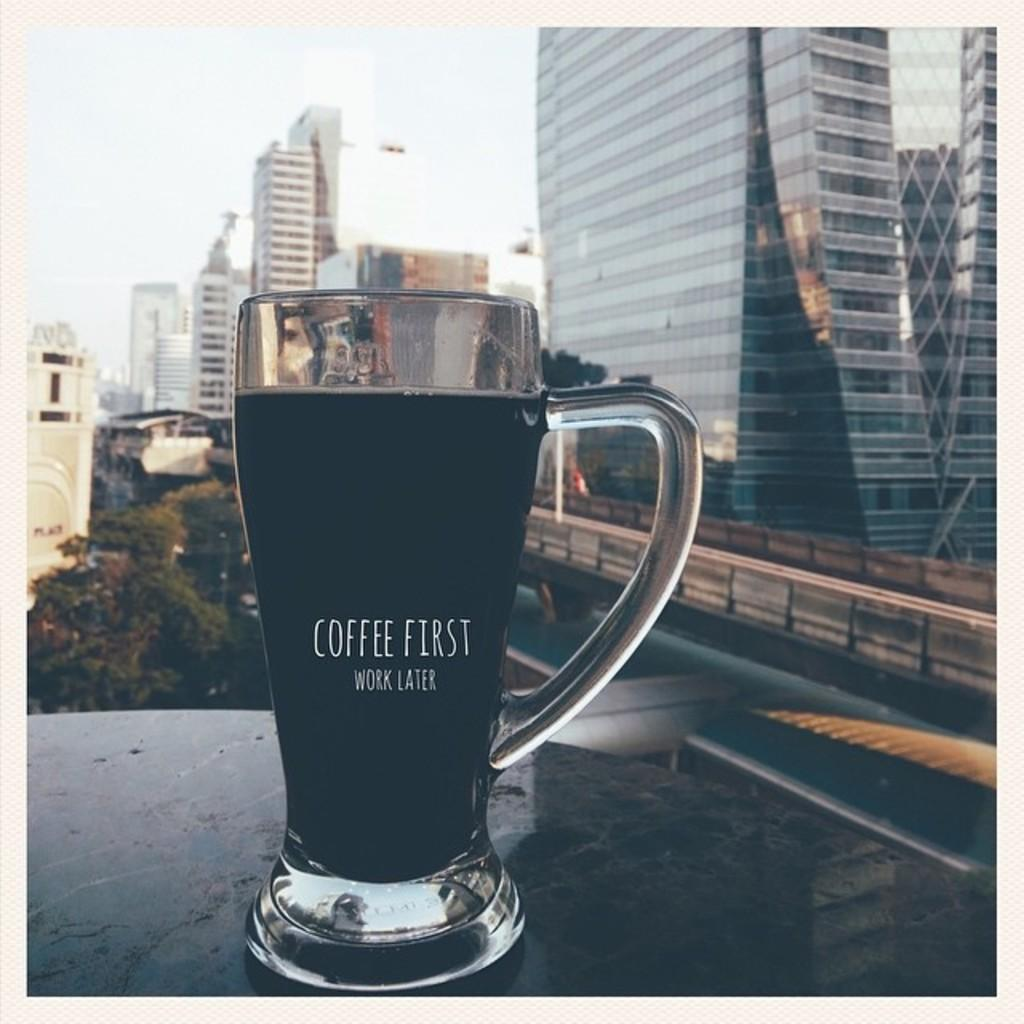<image>
Share a concise interpretation of the image provided. A glass mug that says coffee first work later. 